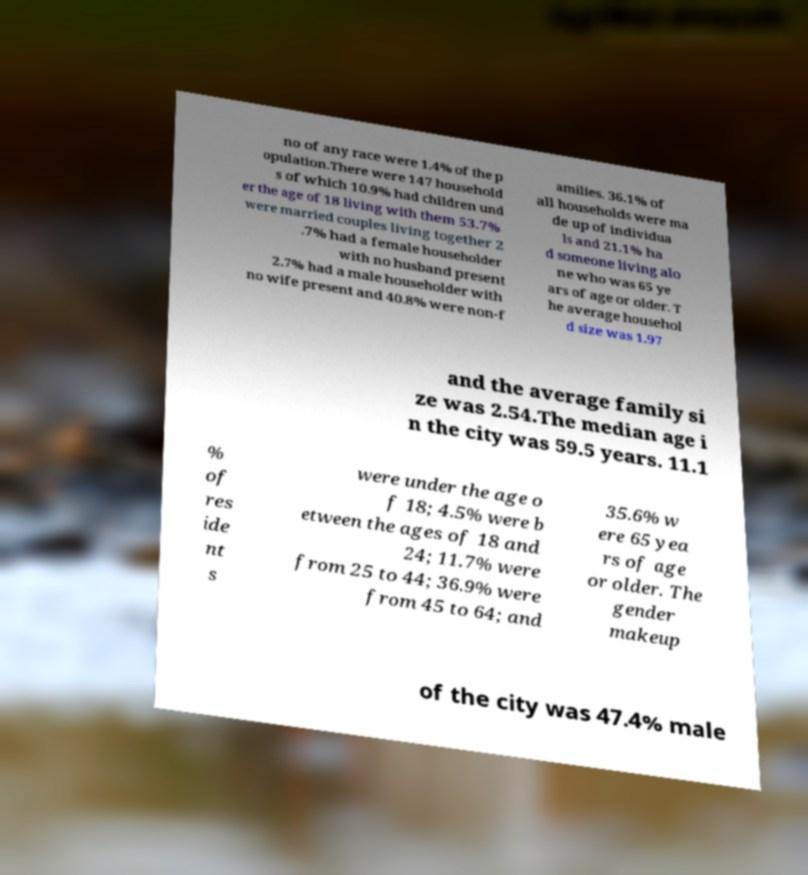Could you assist in decoding the text presented in this image and type it out clearly? no of any race were 1.4% of the p opulation.There were 147 household s of which 10.9% had children und er the age of 18 living with them 53.7% were married couples living together 2 .7% had a female householder with no husband present 2.7% had a male householder with no wife present and 40.8% were non-f amilies. 36.1% of all households were ma de up of individua ls and 21.1% ha d someone living alo ne who was 65 ye ars of age or older. T he average househol d size was 1.97 and the average family si ze was 2.54.The median age i n the city was 59.5 years. 11.1 % of res ide nt s were under the age o f 18; 4.5% were b etween the ages of 18 and 24; 11.7% were from 25 to 44; 36.9% were from 45 to 64; and 35.6% w ere 65 yea rs of age or older. The gender makeup of the city was 47.4% male 